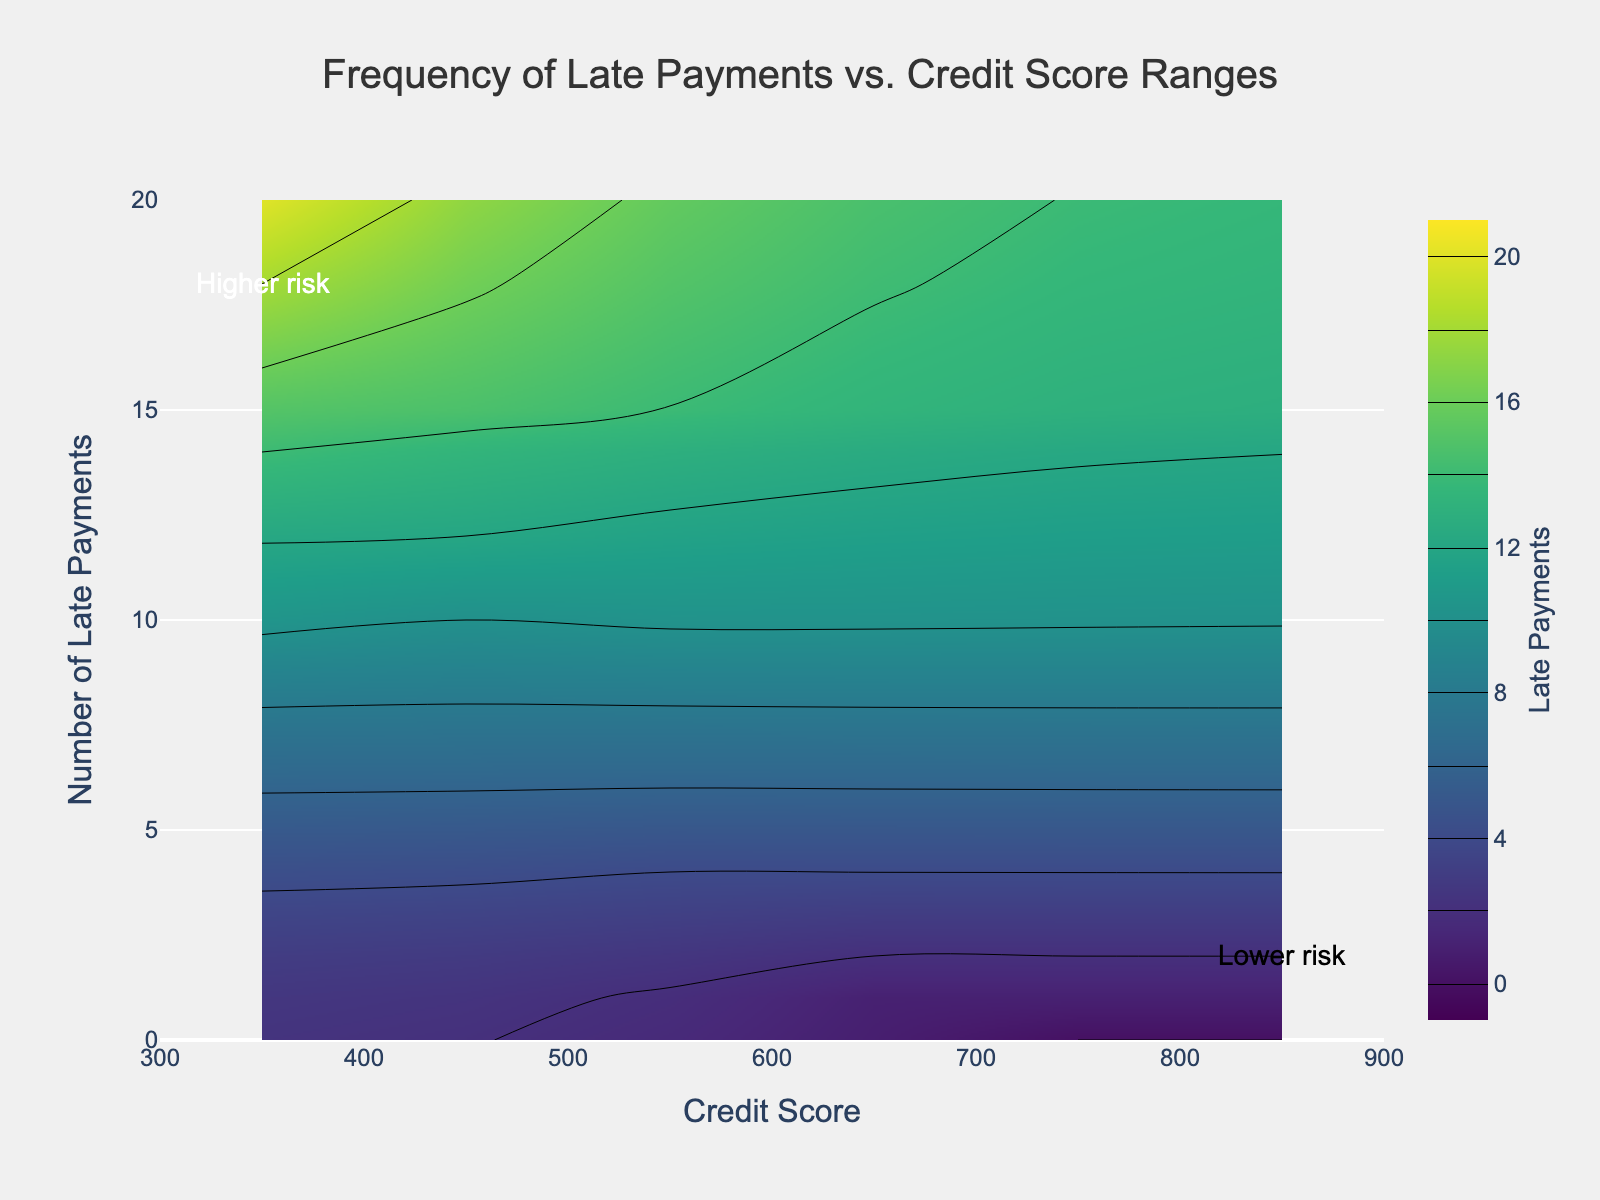What is the title of the contour plot? According to the figure, the title is located at the top and reads, "Frequency of Late Payments vs. Credit Score Ranges".
Answer: Frequency of Late Payments vs. Credit Score Ranges What does the color bar represent? The color bar on the right side of the plot is labeled "Late Payments," representing the range of the number of late payments, with different colors indicating different frequencies.
Answer: Late Payments What's the relationship between credit score and the number of late payments? The plot shows that individuals with higher credit scores generally have fewer late payments, as indicated by the shift in color from regions of high frequency to low frequency when moving towards higher credit score ranges.
Answer: Higher credit score correlates with fewer late payments Where on the plot is the "Higher risk" annotation located? The "Higher risk" annotation is located on the left side of the plot, near the bottom, around the start of the 300-400 credit score range and 18 late payments.
Answer: Near the start of the 300-400 range and 18 late payments Which credit score ranges seem to have spikes in late payment frequencies? Looking at the contour density, the credit score range of 300-400 displays the most significant spikes in late payment frequencies.
Answer: 300-400 How does the number of late payments change from the 400-500 to the 600-700 credit score ranges? By observing the color changes between these ranges, the number of late payments decreases significantly, with the colors indicating lower frequencies as we move from 400-500 to 600-700.
Answer: Decreases significantly What is the average number of late payments for the 300-400 and 500-600 credit score ranges combined? Adding the late payments for 300-400 (15, 18, 14, 20 = 67) and 500-600 (6, 7, 5, 4 = 22), the total is 67 + 22 = 89. The number of entries is 4 + 4 = 8. The average is 89 / 8 = 11.125.
Answer: 11.125 Is there any credit score range that has zero late payments? According to the color distribution and the data representation on the plot, the 800-900 credit score range has consistently zero late payments.
Answer: 800-900 Between the credit score ranges of 600-700 and 700-800, which has a higher maximum number of late payments? The plot indicates that the 600-700 credit score range has a maximum of 3 late payments, whereas the 700-800 range shows a maximum of 1 late payment.
Answer: 600-700 From 300 to 900, how does the risk level change based on late payments? The plot annotations and color gradients show that higher risk (higher late payments) is associated with lower credit scores (300-400), and lower risk (fewer late payments) is associated with higher credit scores (800-900).
Answer: Risk decreases 